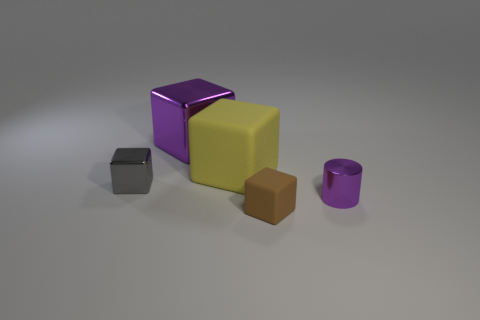Does the small thing on the right side of the tiny rubber thing have the same color as the metallic block that is on the right side of the tiny metallic cube?
Provide a short and direct response. Yes. What shape is the gray object?
Make the answer very short. Cube. There is a brown rubber block; how many tiny metal objects are to the left of it?
Provide a short and direct response. 1. What number of gray spheres are the same material as the big purple thing?
Make the answer very short. 0. Are the big cube that is to the left of the yellow matte object and the yellow object made of the same material?
Your answer should be compact. No. Are there any blue cylinders?
Keep it short and to the point. No. What size is the thing that is both to the right of the yellow rubber block and behind the brown rubber cube?
Keep it short and to the point. Small. Is the number of rubber objects in front of the big matte thing greater than the number of large matte things that are in front of the cylinder?
Offer a terse response. Yes. What size is the thing that is the same color as the large shiny cube?
Make the answer very short. Small. What is the color of the small shiny cylinder?
Ensure brevity in your answer.  Purple. 